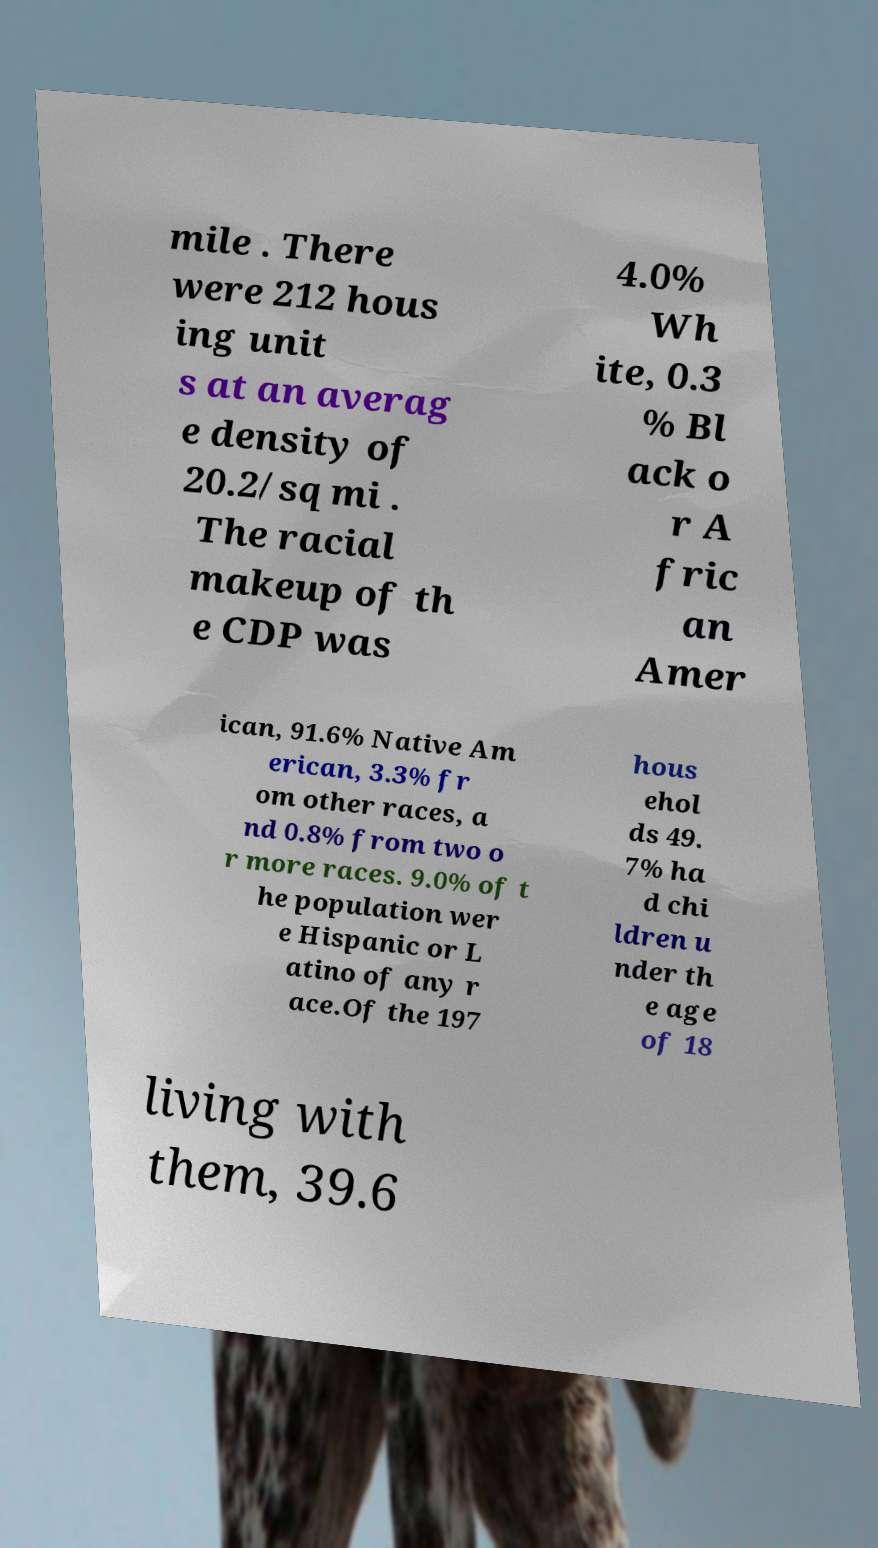For documentation purposes, I need the text within this image transcribed. Could you provide that? mile . There were 212 hous ing unit s at an averag e density of 20.2/sq mi . The racial makeup of th e CDP was 4.0% Wh ite, 0.3 % Bl ack o r A fric an Amer ican, 91.6% Native Am erican, 3.3% fr om other races, a nd 0.8% from two o r more races. 9.0% of t he population wer e Hispanic or L atino of any r ace.Of the 197 hous ehol ds 49. 7% ha d chi ldren u nder th e age of 18 living with them, 39.6 